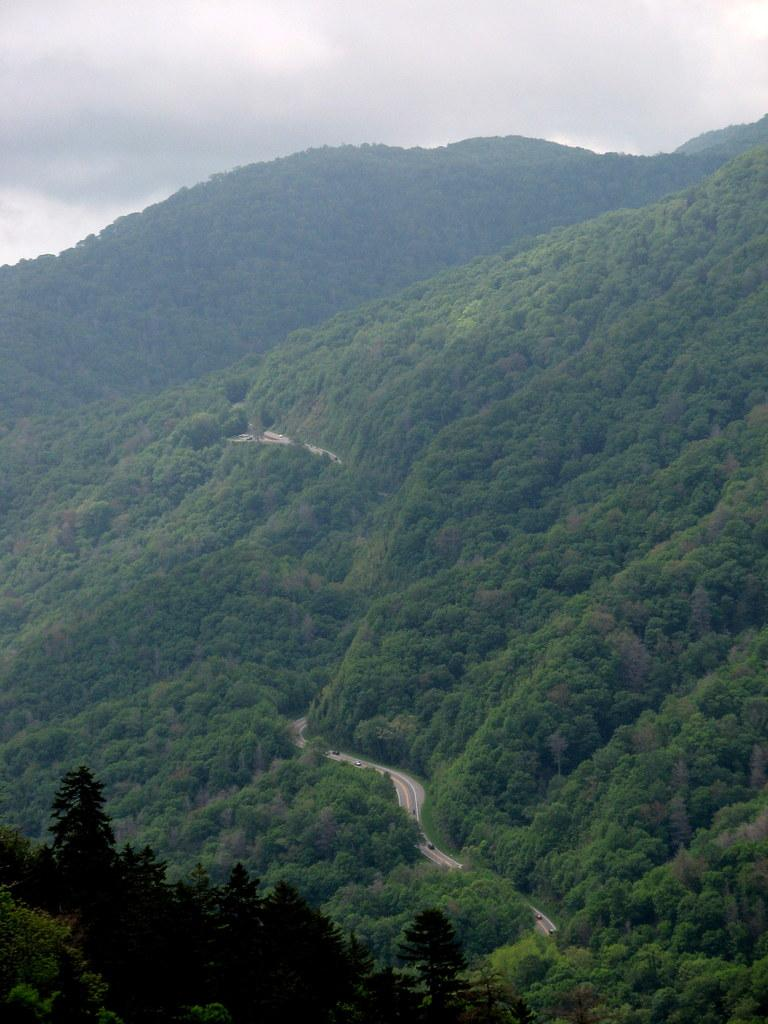What is the main feature of the image? There is a road in the image. What can be seen on the road? There are vehicles on the road. What type of natural elements are visible in the image? There are trees and mountains visible in the image. What is visible above the road and natural elements? The sky is visible in the image. What type of blade can be seen cutting through the roots of the trees in the image? There is no blade or roots visible in the image; it features a road, vehicles, trees, mountains, and the sky. 